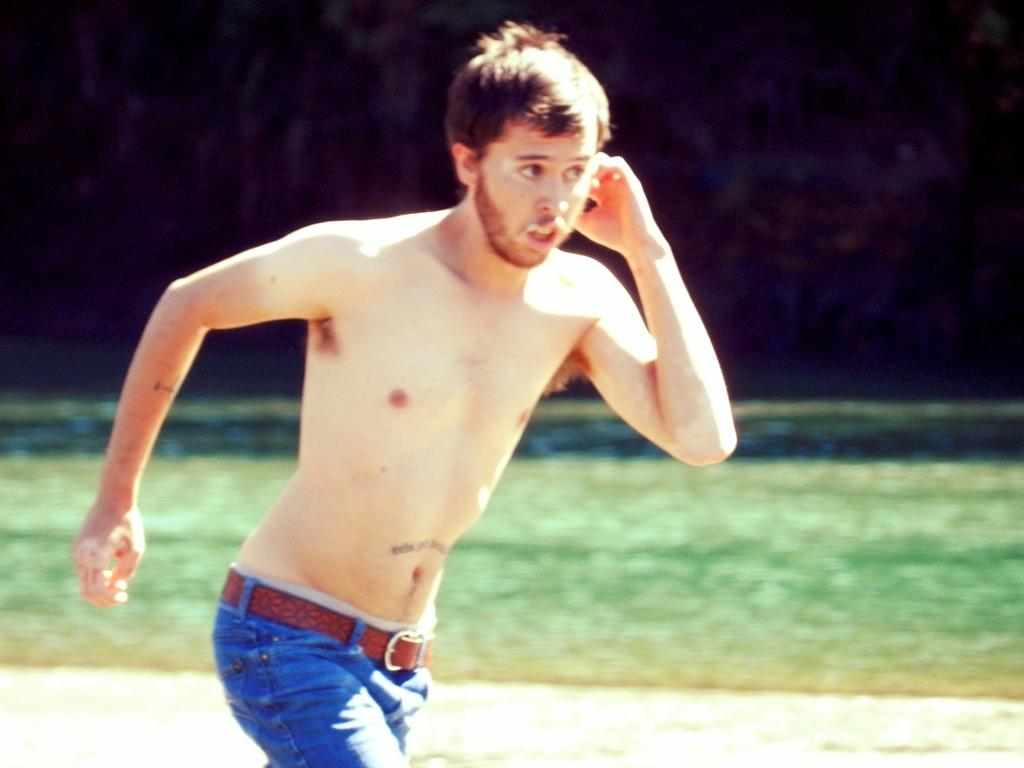Who is the main subject in the image? There is a man in the image. What is the man doing in the image? The man is running. What type of clothing is the man wearing in the image? The man is wearing pants and a belt. Can you describe the background of the image? The background of the image is blurry. What type of drum can be heard in the image? There is no drum or sound present in the image; it is a still photograph of a man running. Is there a jar visible in the image? There is no jar present in the image. 